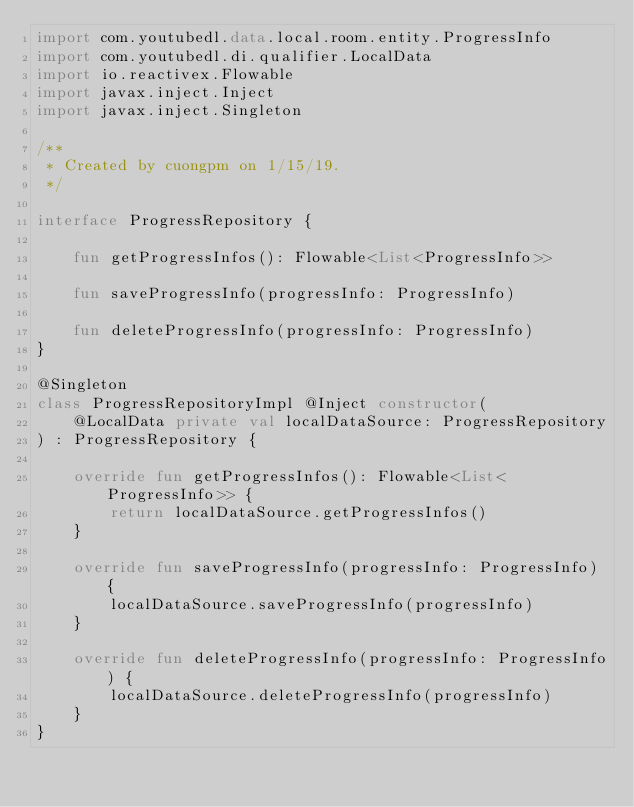<code> <loc_0><loc_0><loc_500><loc_500><_Kotlin_>import com.youtubedl.data.local.room.entity.ProgressInfo
import com.youtubedl.di.qualifier.LocalData
import io.reactivex.Flowable
import javax.inject.Inject
import javax.inject.Singleton

/**
 * Created by cuongpm on 1/15/19.
 */

interface ProgressRepository {

    fun getProgressInfos(): Flowable<List<ProgressInfo>>

    fun saveProgressInfo(progressInfo: ProgressInfo)

    fun deleteProgressInfo(progressInfo: ProgressInfo)
}

@Singleton
class ProgressRepositoryImpl @Inject constructor(
    @LocalData private val localDataSource: ProgressRepository
) : ProgressRepository {

    override fun getProgressInfos(): Flowable<List<ProgressInfo>> {
        return localDataSource.getProgressInfos()
    }

    override fun saveProgressInfo(progressInfo: ProgressInfo) {
        localDataSource.saveProgressInfo(progressInfo)
    }

    override fun deleteProgressInfo(progressInfo: ProgressInfo) {
        localDataSource.deleteProgressInfo(progressInfo)
    }
}</code> 